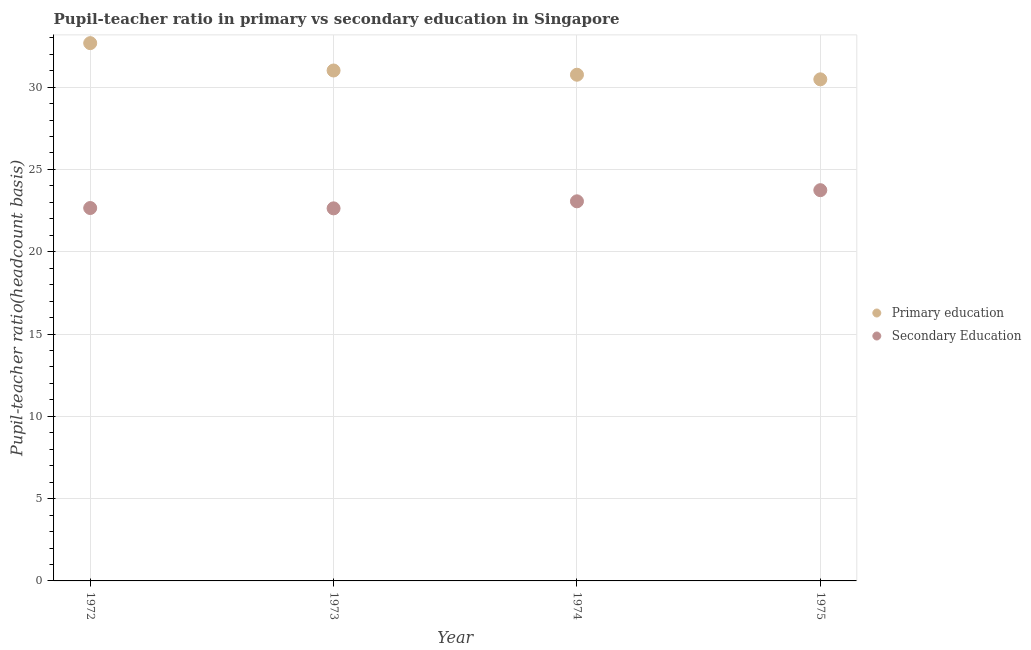Is the number of dotlines equal to the number of legend labels?
Provide a short and direct response. Yes. What is the pupil teacher ratio on secondary education in 1972?
Provide a succinct answer. 22.65. Across all years, what is the maximum pupil-teacher ratio in primary education?
Provide a succinct answer. 32.67. Across all years, what is the minimum pupil teacher ratio on secondary education?
Your response must be concise. 22.63. In which year was the pupil teacher ratio on secondary education maximum?
Your response must be concise. 1975. What is the total pupil teacher ratio on secondary education in the graph?
Make the answer very short. 92.09. What is the difference between the pupil teacher ratio on secondary education in 1972 and that in 1975?
Offer a terse response. -1.08. What is the difference between the pupil-teacher ratio in primary education in 1972 and the pupil teacher ratio on secondary education in 1973?
Give a very brief answer. 10.04. What is the average pupil-teacher ratio in primary education per year?
Offer a very short reply. 31.23. In the year 1972, what is the difference between the pupil-teacher ratio in primary education and pupil teacher ratio on secondary education?
Offer a terse response. 10.02. In how many years, is the pupil-teacher ratio in primary education greater than 20?
Your answer should be very brief. 4. What is the ratio of the pupil teacher ratio on secondary education in 1972 to that in 1973?
Provide a succinct answer. 1. Is the pupil teacher ratio on secondary education in 1974 less than that in 1975?
Provide a short and direct response. Yes. Is the difference between the pupil teacher ratio on secondary education in 1972 and 1973 greater than the difference between the pupil-teacher ratio in primary education in 1972 and 1973?
Your answer should be very brief. No. What is the difference between the highest and the second highest pupil-teacher ratio in primary education?
Offer a very short reply. 1.66. What is the difference between the highest and the lowest pupil teacher ratio on secondary education?
Give a very brief answer. 1.1. In how many years, is the pupil teacher ratio on secondary education greater than the average pupil teacher ratio on secondary education taken over all years?
Keep it short and to the point. 2. Does the pupil-teacher ratio in primary education monotonically increase over the years?
Provide a short and direct response. No. Is the pupil teacher ratio on secondary education strictly less than the pupil-teacher ratio in primary education over the years?
Keep it short and to the point. Yes. Are the values on the major ticks of Y-axis written in scientific E-notation?
Your answer should be compact. No. Does the graph contain grids?
Provide a short and direct response. Yes. Where does the legend appear in the graph?
Provide a short and direct response. Center right. What is the title of the graph?
Make the answer very short. Pupil-teacher ratio in primary vs secondary education in Singapore. Does "GDP" appear as one of the legend labels in the graph?
Provide a short and direct response. No. What is the label or title of the X-axis?
Offer a terse response. Year. What is the label or title of the Y-axis?
Offer a terse response. Pupil-teacher ratio(headcount basis). What is the Pupil-teacher ratio(headcount basis) in Primary education in 1972?
Make the answer very short. 32.67. What is the Pupil-teacher ratio(headcount basis) of Secondary Education in 1972?
Provide a succinct answer. 22.65. What is the Pupil-teacher ratio(headcount basis) in Primary education in 1973?
Provide a short and direct response. 31.01. What is the Pupil-teacher ratio(headcount basis) in Secondary Education in 1973?
Make the answer very short. 22.63. What is the Pupil-teacher ratio(headcount basis) of Primary education in 1974?
Offer a very short reply. 30.75. What is the Pupil-teacher ratio(headcount basis) in Secondary Education in 1974?
Your answer should be very brief. 23.06. What is the Pupil-teacher ratio(headcount basis) in Primary education in 1975?
Ensure brevity in your answer.  30.47. What is the Pupil-teacher ratio(headcount basis) in Secondary Education in 1975?
Offer a terse response. 23.74. Across all years, what is the maximum Pupil-teacher ratio(headcount basis) in Primary education?
Your answer should be compact. 32.67. Across all years, what is the maximum Pupil-teacher ratio(headcount basis) in Secondary Education?
Your answer should be compact. 23.74. Across all years, what is the minimum Pupil-teacher ratio(headcount basis) in Primary education?
Your answer should be compact. 30.47. Across all years, what is the minimum Pupil-teacher ratio(headcount basis) in Secondary Education?
Offer a very short reply. 22.63. What is the total Pupil-teacher ratio(headcount basis) in Primary education in the graph?
Your response must be concise. 124.91. What is the total Pupil-teacher ratio(headcount basis) of Secondary Education in the graph?
Ensure brevity in your answer.  92.09. What is the difference between the Pupil-teacher ratio(headcount basis) in Primary education in 1972 and that in 1973?
Your response must be concise. 1.66. What is the difference between the Pupil-teacher ratio(headcount basis) of Secondary Education in 1972 and that in 1973?
Offer a very short reply. 0.02. What is the difference between the Pupil-teacher ratio(headcount basis) of Primary education in 1972 and that in 1974?
Your answer should be compact. 1.92. What is the difference between the Pupil-teacher ratio(headcount basis) of Secondary Education in 1972 and that in 1974?
Give a very brief answer. -0.41. What is the difference between the Pupil-teacher ratio(headcount basis) in Primary education in 1972 and that in 1975?
Offer a very short reply. 2.2. What is the difference between the Pupil-teacher ratio(headcount basis) in Secondary Education in 1972 and that in 1975?
Offer a very short reply. -1.08. What is the difference between the Pupil-teacher ratio(headcount basis) in Primary education in 1973 and that in 1974?
Give a very brief answer. 0.26. What is the difference between the Pupil-teacher ratio(headcount basis) in Secondary Education in 1973 and that in 1974?
Your answer should be very brief. -0.43. What is the difference between the Pupil-teacher ratio(headcount basis) in Primary education in 1973 and that in 1975?
Your response must be concise. 0.54. What is the difference between the Pupil-teacher ratio(headcount basis) in Secondary Education in 1973 and that in 1975?
Give a very brief answer. -1.1. What is the difference between the Pupil-teacher ratio(headcount basis) of Primary education in 1974 and that in 1975?
Your answer should be very brief. 0.28. What is the difference between the Pupil-teacher ratio(headcount basis) in Secondary Education in 1974 and that in 1975?
Provide a succinct answer. -0.68. What is the difference between the Pupil-teacher ratio(headcount basis) of Primary education in 1972 and the Pupil-teacher ratio(headcount basis) of Secondary Education in 1973?
Your answer should be very brief. 10.04. What is the difference between the Pupil-teacher ratio(headcount basis) of Primary education in 1972 and the Pupil-teacher ratio(headcount basis) of Secondary Education in 1974?
Provide a short and direct response. 9.61. What is the difference between the Pupil-teacher ratio(headcount basis) of Primary education in 1972 and the Pupil-teacher ratio(headcount basis) of Secondary Education in 1975?
Keep it short and to the point. 8.93. What is the difference between the Pupil-teacher ratio(headcount basis) in Primary education in 1973 and the Pupil-teacher ratio(headcount basis) in Secondary Education in 1974?
Your answer should be compact. 7.95. What is the difference between the Pupil-teacher ratio(headcount basis) in Primary education in 1973 and the Pupil-teacher ratio(headcount basis) in Secondary Education in 1975?
Ensure brevity in your answer.  7.27. What is the difference between the Pupil-teacher ratio(headcount basis) in Primary education in 1974 and the Pupil-teacher ratio(headcount basis) in Secondary Education in 1975?
Provide a succinct answer. 7.01. What is the average Pupil-teacher ratio(headcount basis) of Primary education per year?
Your answer should be compact. 31.23. What is the average Pupil-teacher ratio(headcount basis) of Secondary Education per year?
Your answer should be compact. 23.02. In the year 1972, what is the difference between the Pupil-teacher ratio(headcount basis) of Primary education and Pupil-teacher ratio(headcount basis) of Secondary Education?
Offer a very short reply. 10.02. In the year 1973, what is the difference between the Pupil-teacher ratio(headcount basis) in Primary education and Pupil-teacher ratio(headcount basis) in Secondary Education?
Your answer should be compact. 8.37. In the year 1974, what is the difference between the Pupil-teacher ratio(headcount basis) in Primary education and Pupil-teacher ratio(headcount basis) in Secondary Education?
Ensure brevity in your answer.  7.69. In the year 1975, what is the difference between the Pupil-teacher ratio(headcount basis) of Primary education and Pupil-teacher ratio(headcount basis) of Secondary Education?
Your answer should be very brief. 6.73. What is the ratio of the Pupil-teacher ratio(headcount basis) in Primary education in 1972 to that in 1973?
Offer a terse response. 1.05. What is the ratio of the Pupil-teacher ratio(headcount basis) in Primary education in 1972 to that in 1974?
Provide a short and direct response. 1.06. What is the ratio of the Pupil-teacher ratio(headcount basis) of Secondary Education in 1972 to that in 1974?
Offer a very short reply. 0.98. What is the ratio of the Pupil-teacher ratio(headcount basis) in Primary education in 1972 to that in 1975?
Make the answer very short. 1.07. What is the ratio of the Pupil-teacher ratio(headcount basis) of Secondary Education in 1972 to that in 1975?
Your answer should be compact. 0.95. What is the ratio of the Pupil-teacher ratio(headcount basis) in Primary education in 1973 to that in 1974?
Your answer should be very brief. 1.01. What is the ratio of the Pupil-teacher ratio(headcount basis) of Secondary Education in 1973 to that in 1974?
Give a very brief answer. 0.98. What is the ratio of the Pupil-teacher ratio(headcount basis) of Primary education in 1973 to that in 1975?
Your answer should be compact. 1.02. What is the ratio of the Pupil-teacher ratio(headcount basis) in Secondary Education in 1973 to that in 1975?
Ensure brevity in your answer.  0.95. What is the ratio of the Pupil-teacher ratio(headcount basis) in Primary education in 1974 to that in 1975?
Provide a succinct answer. 1.01. What is the ratio of the Pupil-teacher ratio(headcount basis) of Secondary Education in 1974 to that in 1975?
Offer a terse response. 0.97. What is the difference between the highest and the second highest Pupil-teacher ratio(headcount basis) in Primary education?
Keep it short and to the point. 1.66. What is the difference between the highest and the second highest Pupil-teacher ratio(headcount basis) of Secondary Education?
Offer a terse response. 0.68. What is the difference between the highest and the lowest Pupil-teacher ratio(headcount basis) in Primary education?
Offer a very short reply. 2.2. What is the difference between the highest and the lowest Pupil-teacher ratio(headcount basis) of Secondary Education?
Your answer should be very brief. 1.1. 